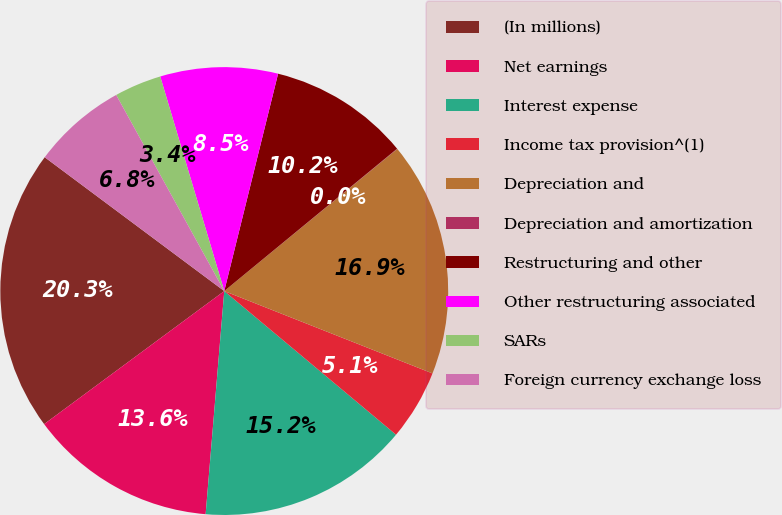<chart> <loc_0><loc_0><loc_500><loc_500><pie_chart><fcel>(In millions)<fcel>Net earnings<fcel>Interest expense<fcel>Income tax provision^(1)<fcel>Depreciation and<fcel>Depreciation and amortization<fcel>Restructuring and other<fcel>Other restructuring associated<fcel>SARs<fcel>Foreign currency exchange loss<nl><fcel>20.32%<fcel>13.55%<fcel>15.24%<fcel>5.09%<fcel>16.94%<fcel>0.02%<fcel>10.17%<fcel>8.48%<fcel>3.4%<fcel>6.79%<nl></chart> 